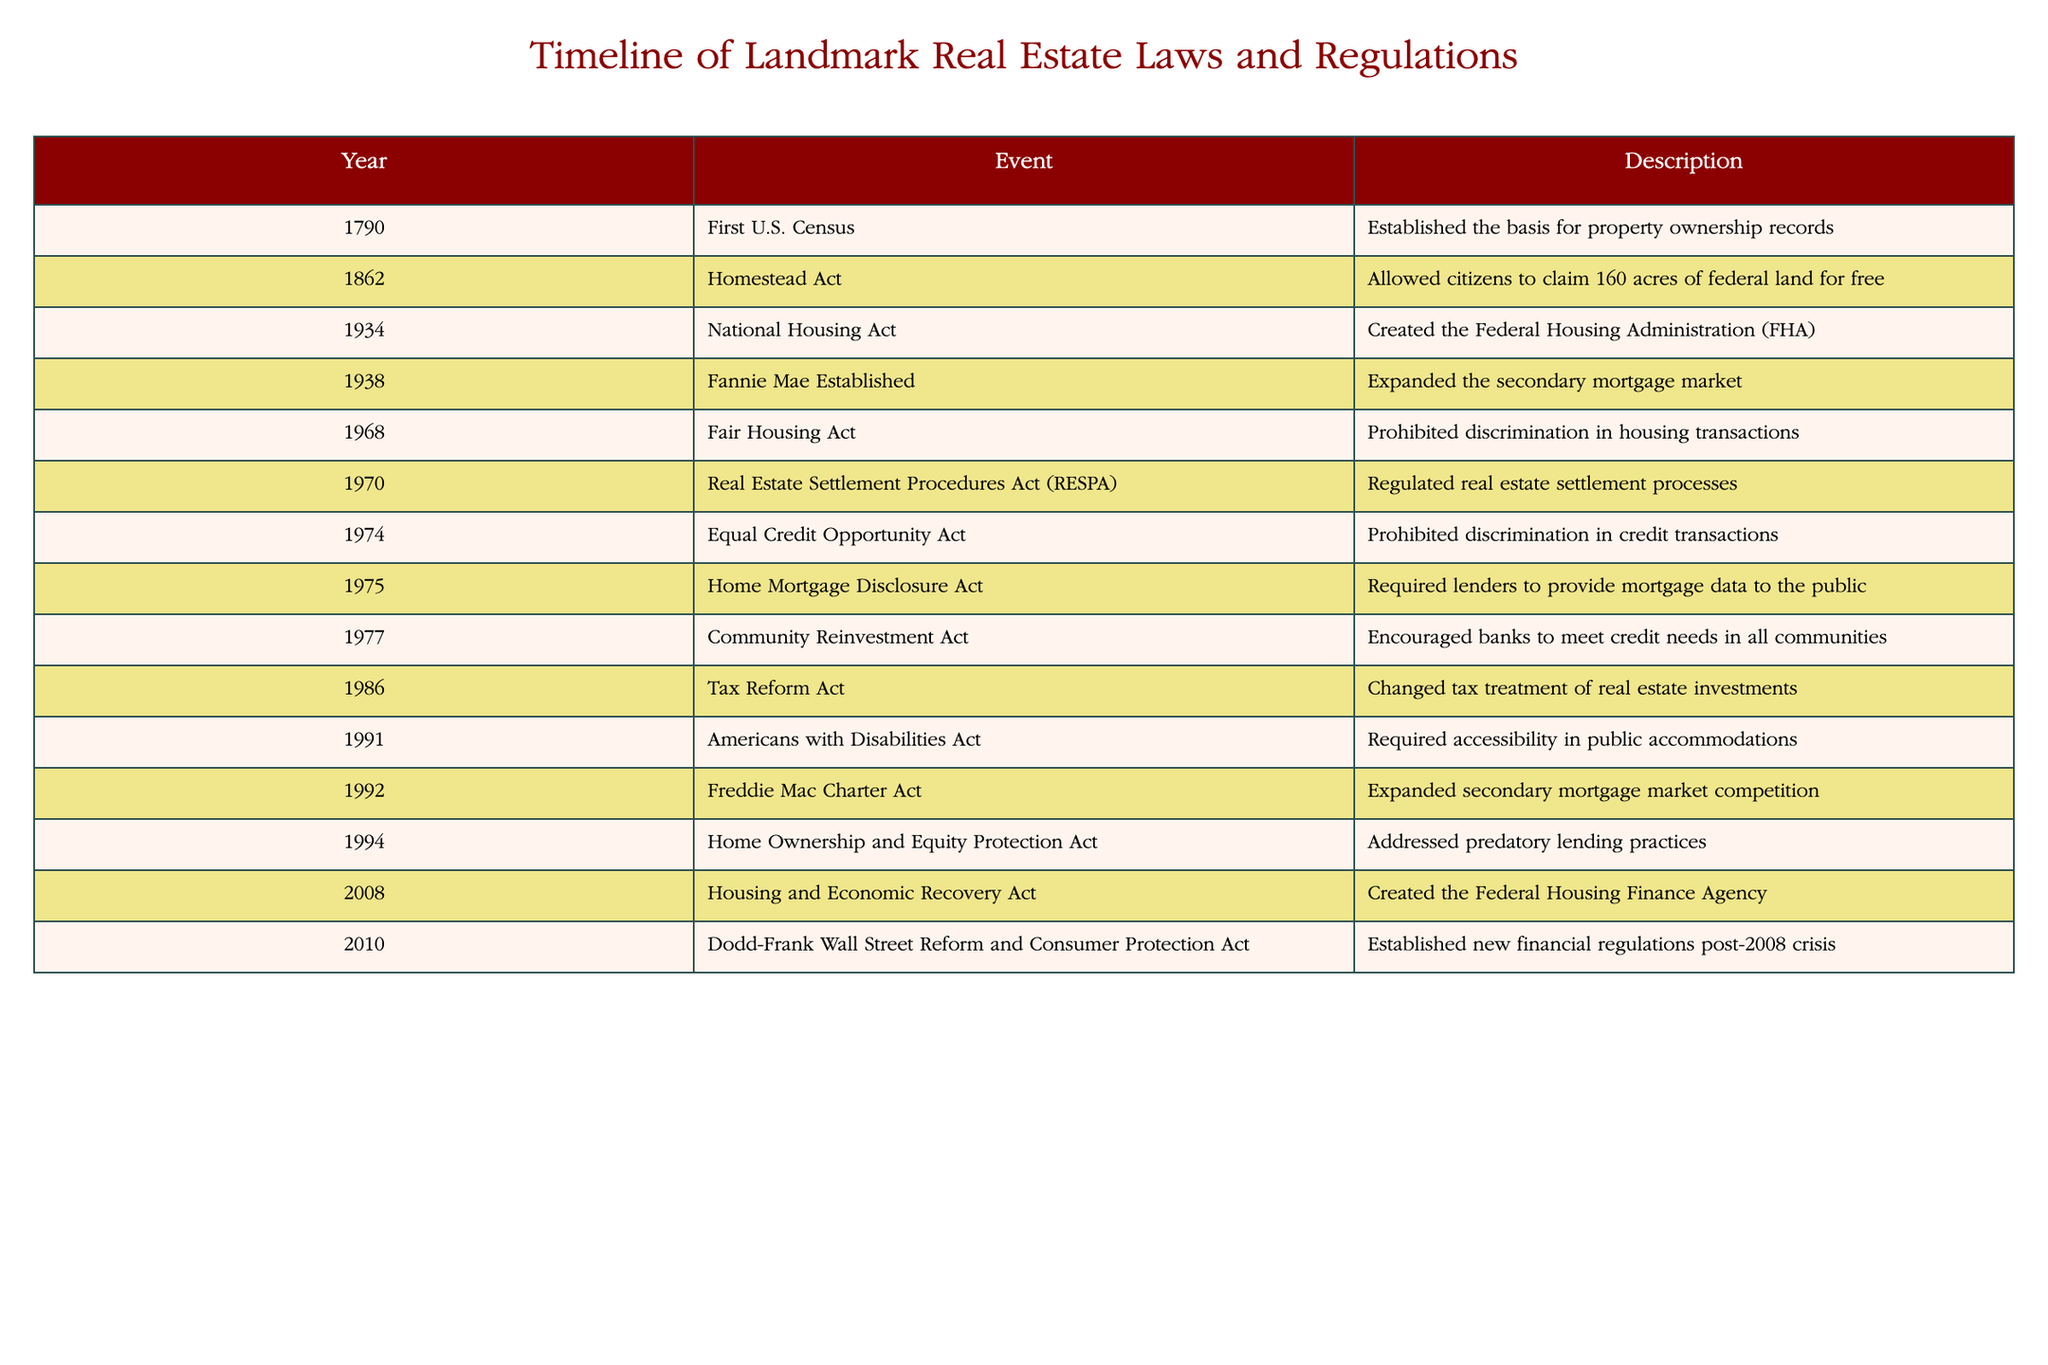What year was the Fair Housing Act enacted? The table lists various events along with their corresponding years. We can see that the Fair Housing Act is listed under the year 1968.
Answer: 1968 Which event took place in 1974? Looking at the table, the event that occurred in 1974 is the Equal Credit Opportunity Act.
Answer: Equal Credit Opportunity Act How many years are there between the establishment of Fannie Mae in 1938 and the enactment of the Americans with Disabilities Act in 1991? To find the number of years between these two events, we subtract the earlier year from the later year: 1991 - 1938 = 53 years.
Answer: 53 Was the National Housing Act established before or after the Homestead Act? By checking the years of both events in the table, we see that the National Housing Act occurred in 1934 and the Homestead Act in 1862. Since 1934 is after 1862, the answer is after.
Answer: After What is the total number of events listed from 1970 onwards? Reviewing the table for events that occurred starting in 1970, we have: Real Estate Settlement Procedures Act (1970), Equal Credit Opportunity Act (1974), Home Mortgage Disclosure Act (1975), Community Reinvestment Act (1977), Tax Reform Act (1986), Americans with Disabilities Act (1991), Freddie Mac Charter Act (1992), Home Ownership and Equity Protection Act (1994), Housing and Economic Recovery Act (2008), Dodd-Frank Act (2010). This gives us a total count of 10 events.
Answer: 10 What two key acts were established in 2008 and 2010, and what are their purposes? The table indicates that in 2008, the Housing and Economic Recovery Act was established, which aimed to address the housing crisis. In 2010, the Dodd-Frank Wall Street Reform and Consumer Protection Act was enacted to establish financial regulations after the 2008 financial crisis.
Answer: Housing and Economic Recovery Act (2008) - address housing crisis; Dodd-Frank Act (2010) - financial regulations Is it true that the Community Reinvestment Act was enacted before the Tax Reform Act? By comparing the years in the table, the Community Reinvestment Act is from 1977 and the Tax Reform Act is from 1986. Since 1977 is earlier than 1986, the statement is true.
Answer: True How many acts in the table were specifically aimed at preventing discrimination in housing or lending practices? We identify the following acts: Fair Housing Act (1968), Equal Credit Opportunity Act (1974), and Home Ownership and Equity Protection Act (1994). This gives us a total of 3 acts aimed at preventing discrimination.
Answer: 3 